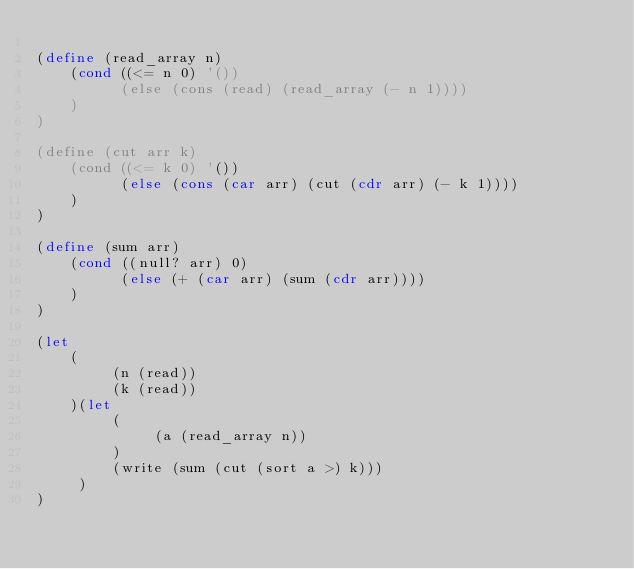<code> <loc_0><loc_0><loc_500><loc_500><_Scheme_>
(define (read_array n)
    (cond ((<= n 0) '())
          (else (cons (read) (read_array (- n 1))))
    )
)

(define (cut arr k)
    (cond ((<= k 0) '())
          (else (cons (car arr) (cut (cdr arr) (- k 1))))
    )
)

(define (sum arr)
    (cond ((null? arr) 0)
          (else (+ (car arr) (sum (cdr arr))))
    )
)

(let
    (
         (n (read))
         (k (read))
    )(let
         (
              (a (read_array n))
         )
         (write (sum (cut (sort a >) k)))
     )
)
               </code> 